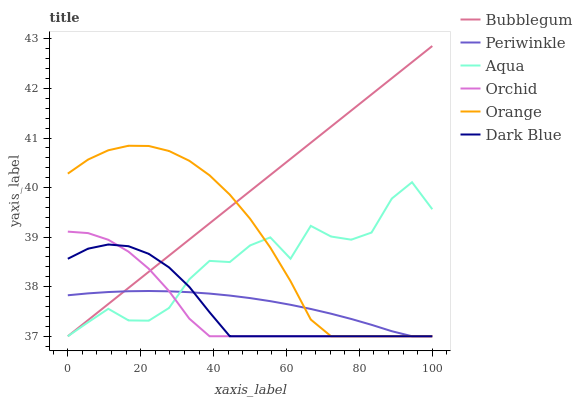Does Orchid have the minimum area under the curve?
Answer yes or no. Yes. Does Bubblegum have the maximum area under the curve?
Answer yes or no. Yes. Does Dark Blue have the minimum area under the curve?
Answer yes or no. No. Does Dark Blue have the maximum area under the curve?
Answer yes or no. No. Is Bubblegum the smoothest?
Answer yes or no. Yes. Is Aqua the roughest?
Answer yes or no. Yes. Is Dark Blue the smoothest?
Answer yes or no. No. Is Dark Blue the roughest?
Answer yes or no. No. Does Aqua have the lowest value?
Answer yes or no. Yes. Does Bubblegum have the highest value?
Answer yes or no. Yes. Does Dark Blue have the highest value?
Answer yes or no. No. Does Dark Blue intersect Periwinkle?
Answer yes or no. Yes. Is Dark Blue less than Periwinkle?
Answer yes or no. No. Is Dark Blue greater than Periwinkle?
Answer yes or no. No. 